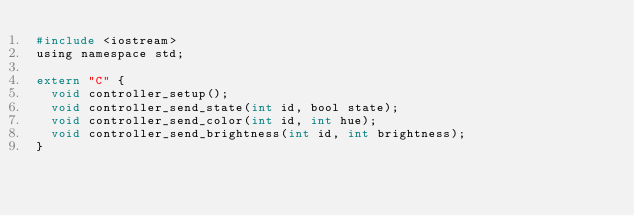Convert code to text. <code><loc_0><loc_0><loc_500><loc_500><_C_>#include <iostream>
using namespace std;

extern "C" {
  void controller_setup();
  void controller_send_state(int id, bool state);
  void controller_send_color(int id, int hue);
  void controller_send_brightness(int id, int brightness);
}
</code> 